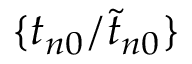<formula> <loc_0><loc_0><loc_500><loc_500>\{ { t _ { n 0 } } / { \widetilde { t } _ { n 0 } } \}</formula> 